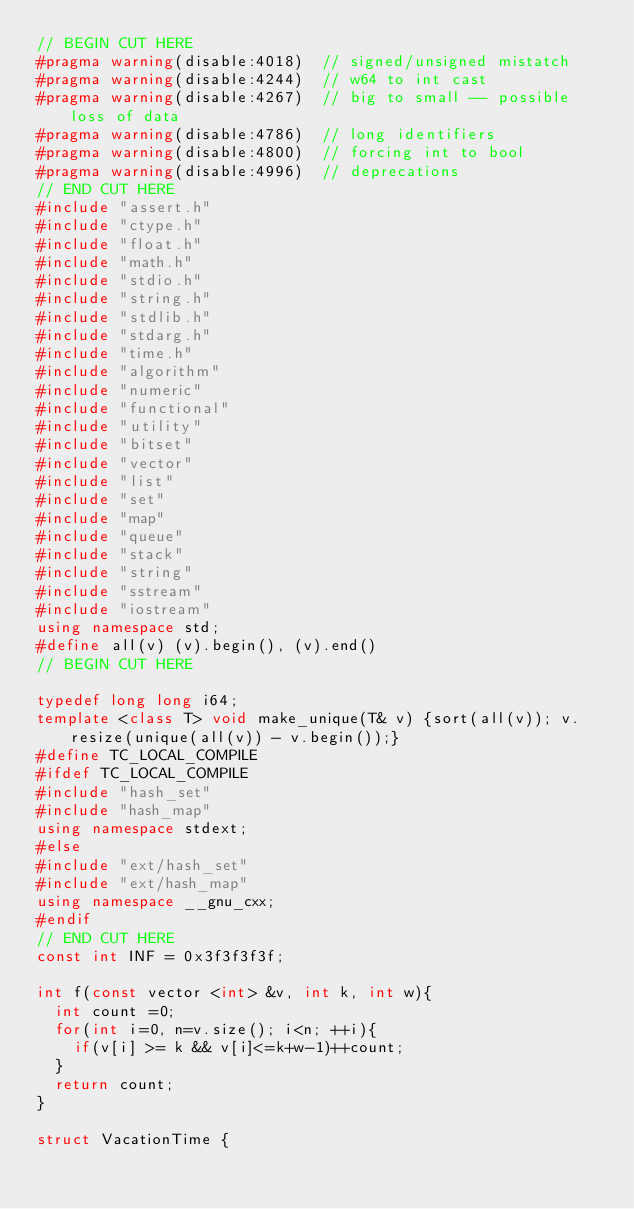<code> <loc_0><loc_0><loc_500><loc_500><_C++_>// BEGIN CUT HERE
#pragma warning(disable:4018)  // signed/unsigned mistatch
#pragma warning(disable:4244)  // w64 to int cast
#pragma warning(disable:4267)  // big to small -- possible loss of data
#pragma warning(disable:4786)  // long identifiers
#pragma warning(disable:4800)  // forcing int to bool
#pragma warning(disable:4996)  // deprecations
// END CUT HERE
#include "assert.h"
#include "ctype.h"
#include "float.h"
#include "math.h"
#include "stdio.h"
#include "string.h"
#include "stdlib.h"
#include "stdarg.h"
#include "time.h"
#include "algorithm"
#include "numeric"
#include "functional"
#include "utility"
#include "bitset"
#include "vector"
#include "list"
#include "set"
#include "map"
#include "queue"
#include "stack"
#include "string"
#include "sstream"
#include "iostream"
using namespace std;
#define all(v) (v).begin(), (v).end()
// BEGIN CUT HERE

typedef long long i64;
template <class T> void make_unique(T& v) {sort(all(v)); v.resize(unique(all(v)) - v.begin());}
#define TC_LOCAL_COMPILE
#ifdef TC_LOCAL_COMPILE
#include "hash_set"
#include "hash_map"
using namespace stdext;
#else
#include "ext/hash_set"
#include "ext/hash_map"
using namespace __gnu_cxx;
#endif
// END CUT HERE
const int INF = 0x3f3f3f3f;

int f(const vector <int> &v, int k, int w){
	int count =0;
	for(int i=0, n=v.size(); i<n; ++i){
		if(v[i] >= k && v[i]<=k+w-1)++count;
	}
	return count;
}

struct VacationTime {</code> 